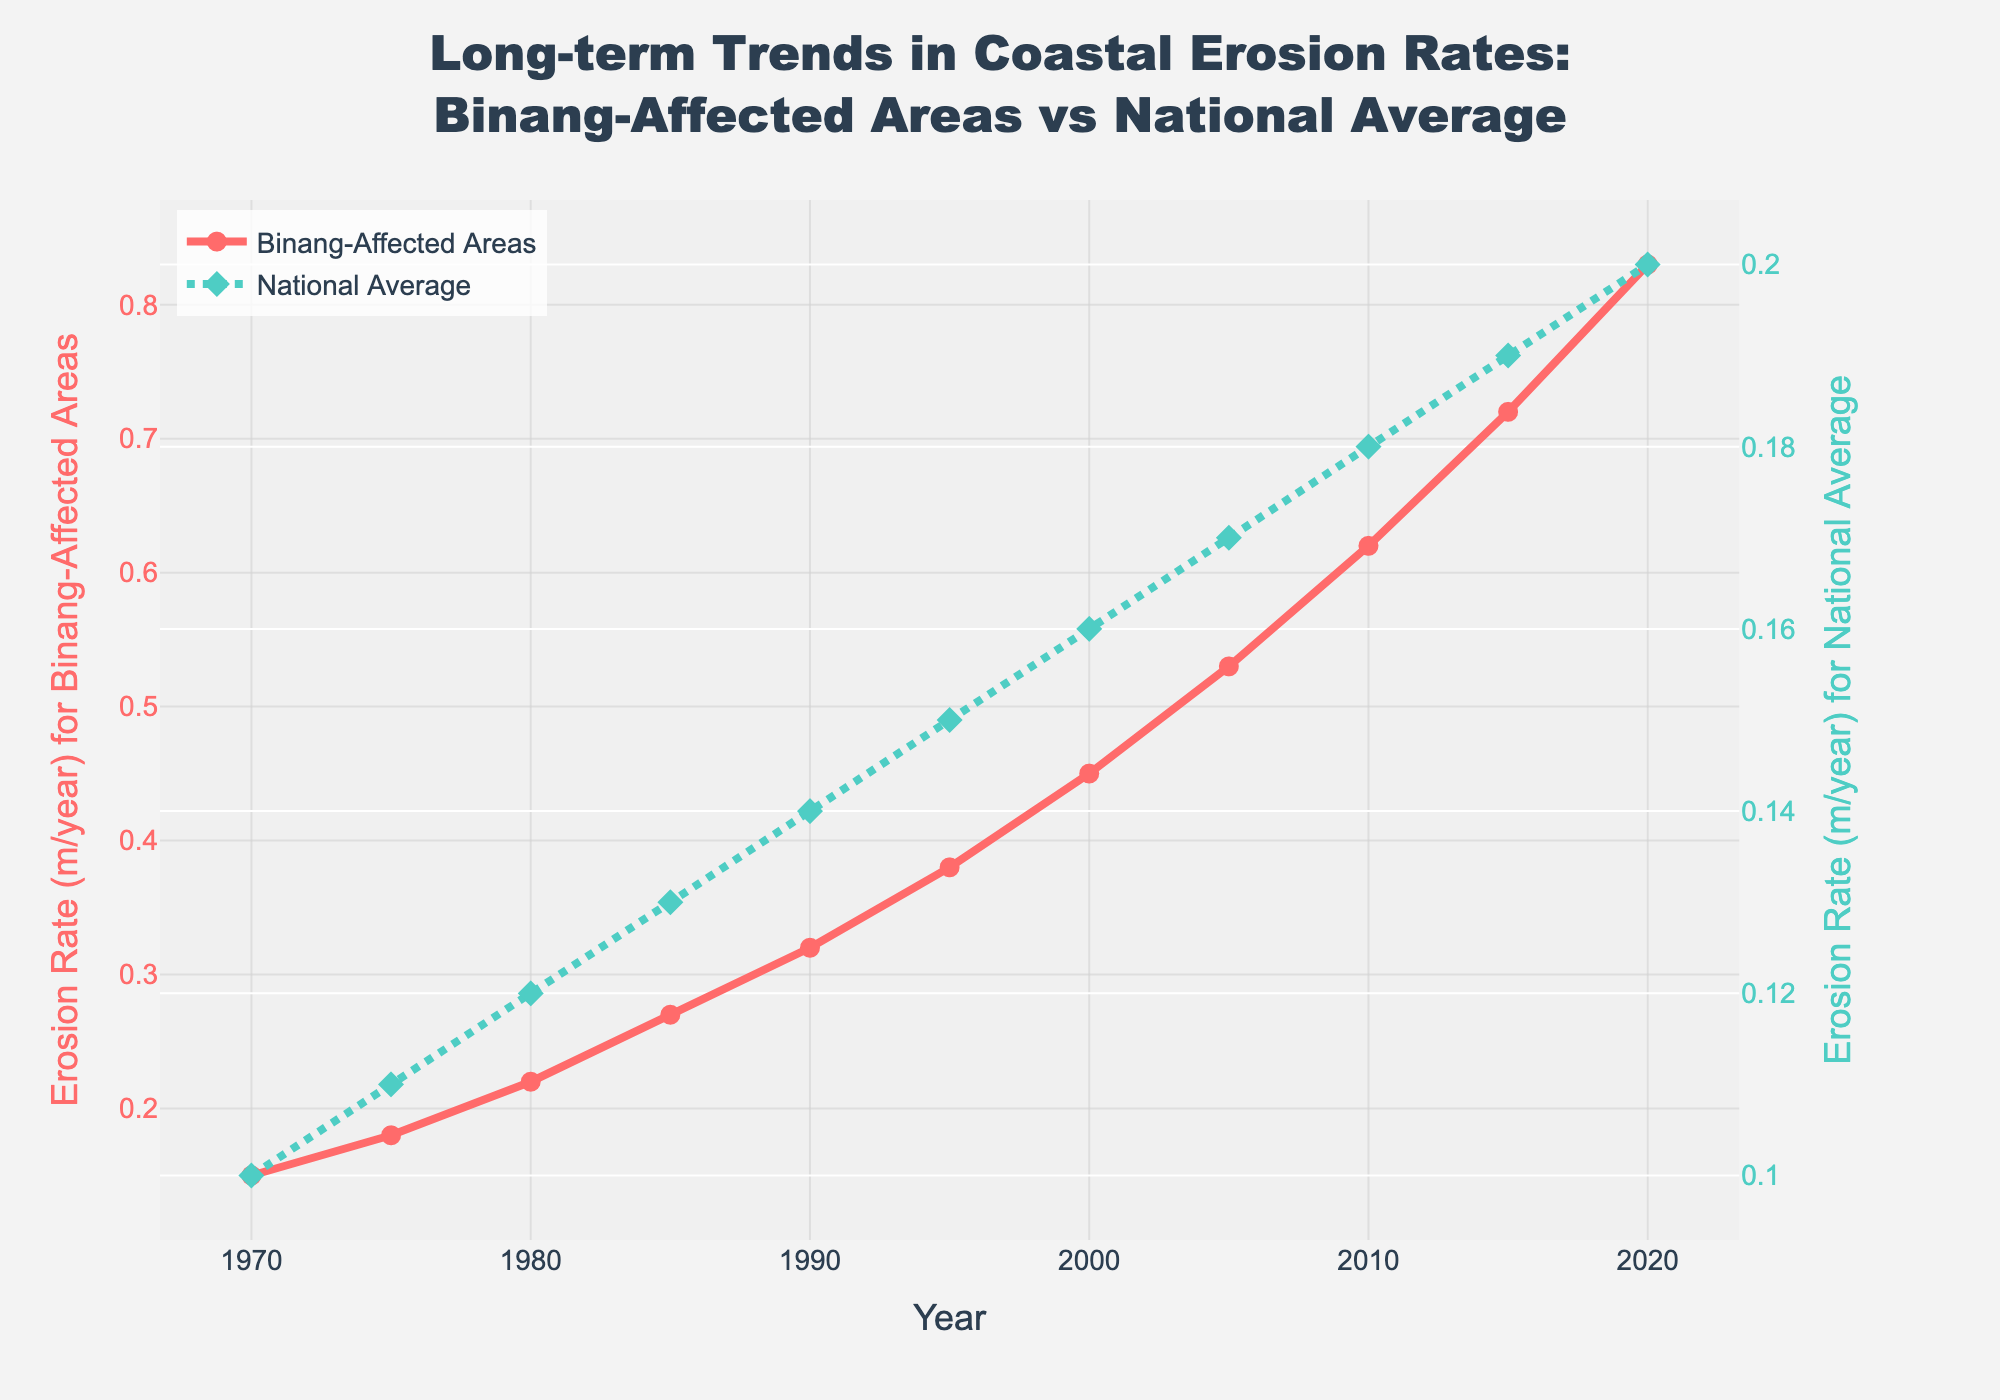What trend do you observe in the erosion rates of Binang-Affected Areas from 1970 to 2020? The erosion rates in Binang-Affected Areas show a clear increasing trend from 0.15 m/year in 1970 to 0.83 m/year in 2020. This indicates that coastal erosion has been intensifying over the years in areas affected by the Binang storms.
Answer: Increasing trend How do the trends in erosion rates for Binang-Affected Areas compare to the national average from 1970 to 2020? Both the Binang-Affected Areas and the national average show increasing erosion rates over time. However, the erosion rate in Binang-Affected Areas increases more rapidly compared to the national average.
Answer: Binang-Affected Areas increase more rapidly What is the difference in erosion rates between Binang-Affected Areas and the National Average in 2020? The erosion rate in Binang-Affected Areas in 2020 is 0.83 m/year, while the national average is 0.20 m/year. The difference is 0.83 - 0.20 = 0.63 m/year.
Answer: 0.63 m/year In which year do Binang-Affected Areas and the National Average erosion rates differ the most? The erosion rates differ the most in 2020. In this year, Binang-Affected Areas have an erosion rate of 0.83 m/year, and the national average is 0.20 m/year. The difference is 0.63 m/year, which is the largest difference observed.
Answer: 2020 What is the average erosion rate for Binang-Affected Areas over the entire period? Sum the erosion rates for Binang-Affected Areas from 1970 to 2020 and divide by the number of years. (0.15 + 0.18 + 0.22 + 0.27 + 0.32 + 0.38 + 0.45 + 0.53 + 0.62 + 0.72 + 0.83) / 11 =  4.67 / 11 ≈ 0.42 m/year
Answer: 0.42 m/year Which year shows the sharpest increase in erosion rates for Binang-Affected Areas, and what is the rate of increase? The sharpest increase is between 1970 and 1975, with an increase from 0.15 m/year to 0.18 m/year. The rate of increase is 0.18 - 0.15 = 0.03 m/year.
Answer: 1970-1975, 0.03 m/year By how much did the national average erosion rate increase from 1970 to 2020? The national average erosion rate in 1970 was 0.10 m/year, and in 2020 it was 0.20 m/year. The increase is 0.20 - 0.10 = 0.10 m/year.
Answer: 0.10 m/year What color represents the erosion rate for Binang-Affected Areas in the plot? The line representing the erosion rate for Binang-Affected Areas is shown in red.
Answer: Red 